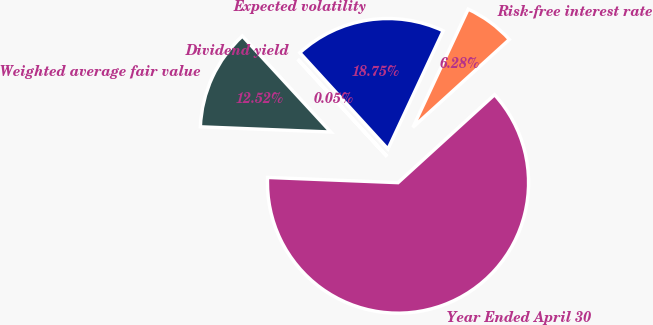<chart> <loc_0><loc_0><loc_500><loc_500><pie_chart><fcel>Year Ended April 30<fcel>Risk-free interest rate<fcel>Expected volatility<fcel>Dividend yield<fcel>Weighted average fair value<nl><fcel>62.39%<fcel>6.28%<fcel>18.75%<fcel>0.05%<fcel>12.52%<nl></chart> 